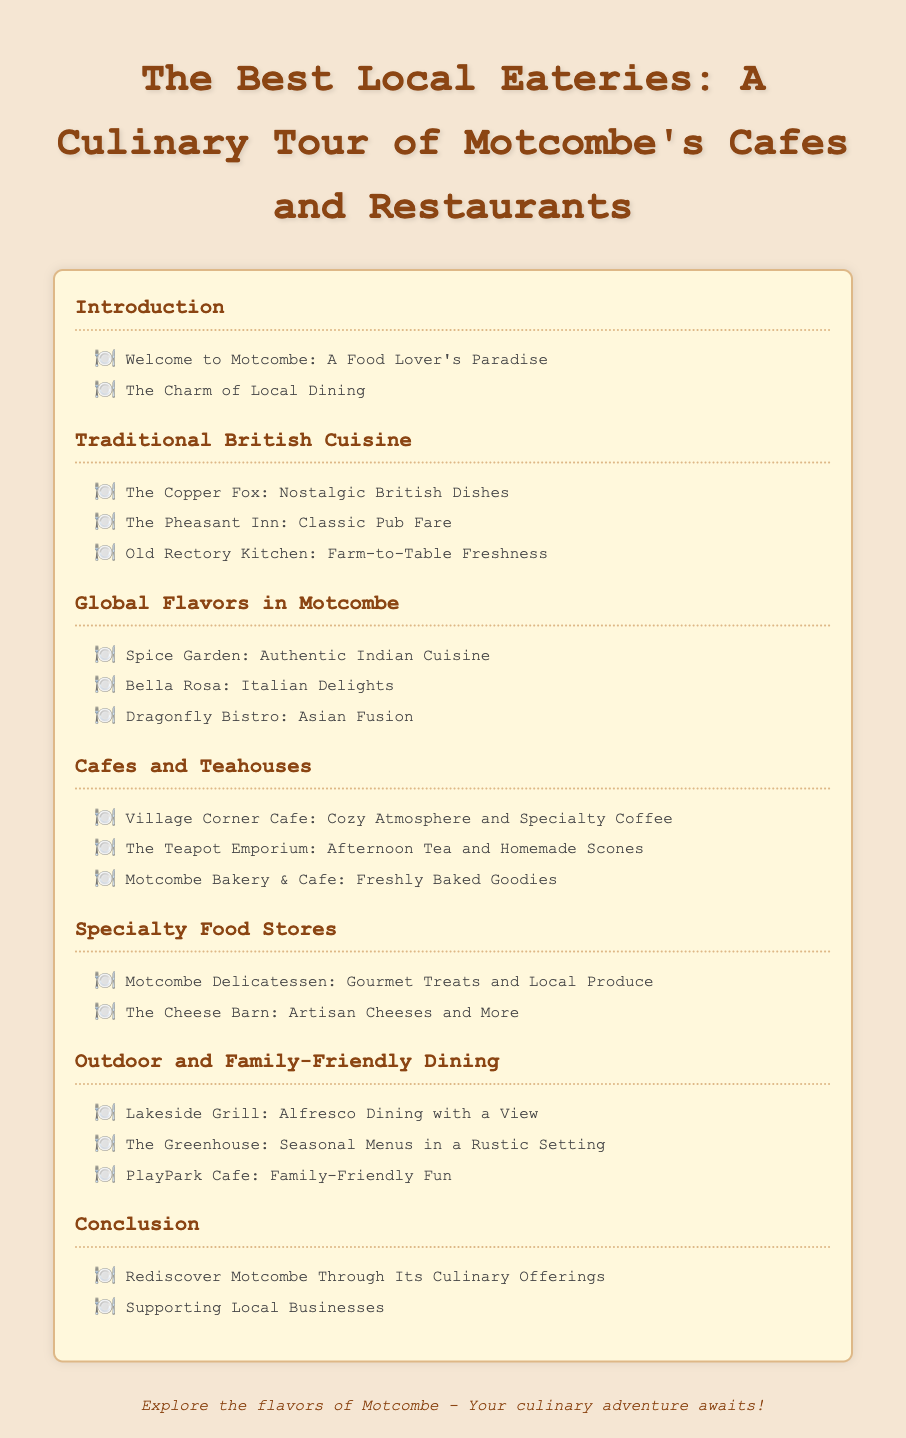What is the title of the document? The title is the main heading of the document, which introduces the subject matter.
Answer: The Best Local Eateries: A Culinary Tour of Motcombe's Cafes and Restaurants How many sections are there in the Table of Contents? The number of sections is determined by the distinct headings in the Table of Contents.
Answer: 6 What is the first eatery listed under Traditional British Cuisine? This question focuses on retrieving the specific name of the first eatery from a section.
Answer: The Copper Fox Which eatery specializes in Italian cuisine? The question seeks to identify the restaurant that represents Italian food in the document.
Answer: Bella Rosa What type of dining experience does Lakeside Grill offer? This question aims to determine the nature of the dining experience provided by a specific eatery.
Answer: Alfresco Dining with a View How many cafes are mentioned in the Cafes and Teahouses section? The count of specific types of establishments is derived from the relevant section heading.
Answer: 3 What is emphasized in the conclusion of the document? The conclusion presents important final thoughts that encapsulate the document's message.
Answer: Supporting Local Businesses Which eatery is known for homemade scones? This question asks for the specific cafe that features homemade scones on its menu.
Answer: The Teapot Emporium What is the focus of the Global Flavors in Motcombe section? This question addresses the theme or type of cuisine highlighted in a specific section.
Answer: International cuisine 